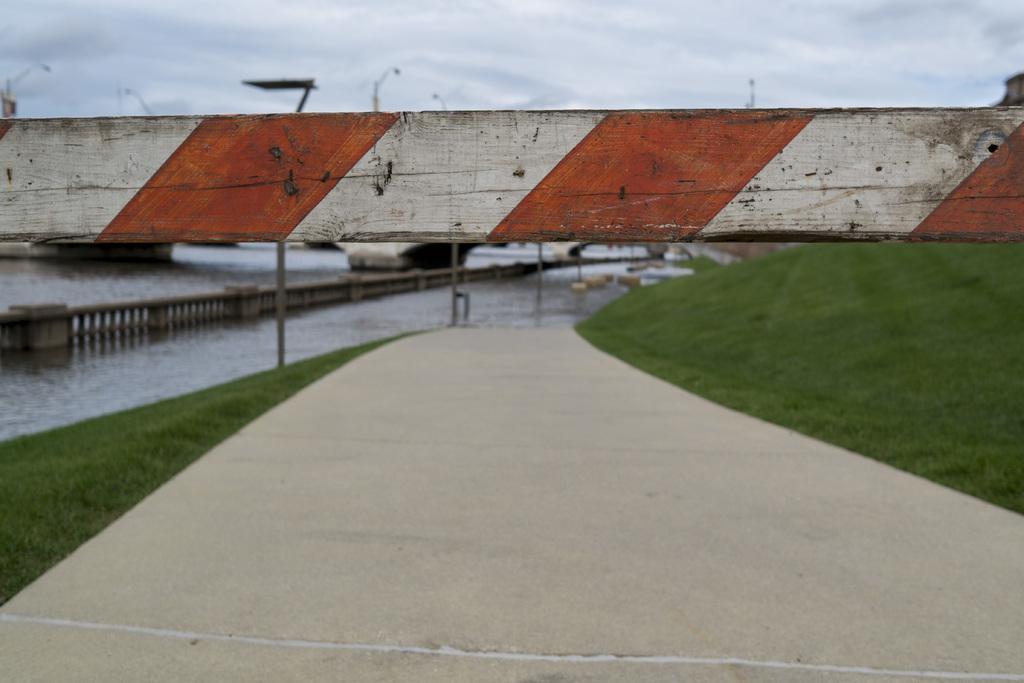Could you give a brief overview of what you see in this image? There is a road. On the sides of the road there are grass lawns. Also there is a bridge. There is water. There is a bridge in the water also. In the background there is sky. 